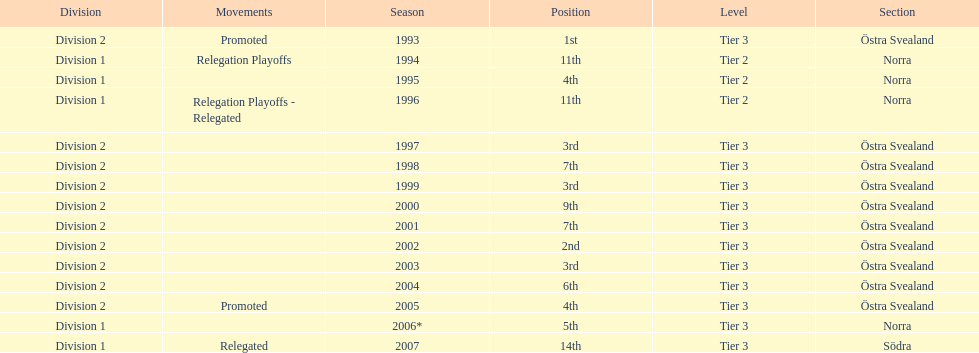They placed third in 2003. when did they place third before that? 1999. 